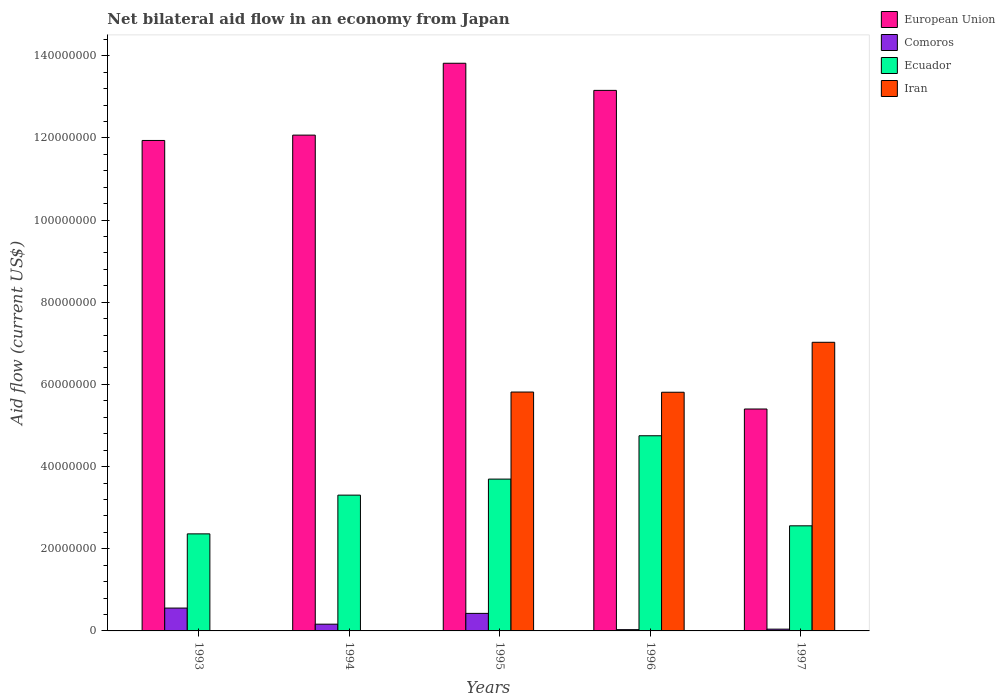How many groups of bars are there?
Keep it short and to the point. 5. Are the number of bars per tick equal to the number of legend labels?
Offer a very short reply. No. Are the number of bars on each tick of the X-axis equal?
Make the answer very short. No. Across all years, what is the maximum net bilateral aid flow in European Union?
Your answer should be compact. 1.38e+08. Across all years, what is the minimum net bilateral aid flow in European Union?
Give a very brief answer. 5.40e+07. In which year was the net bilateral aid flow in Ecuador maximum?
Give a very brief answer. 1996. What is the total net bilateral aid flow in Comoros in the graph?
Your answer should be compact. 1.22e+07. What is the difference between the net bilateral aid flow in Comoros in 1993 and that in 1994?
Make the answer very short. 3.92e+06. What is the difference between the net bilateral aid flow in Ecuador in 1997 and the net bilateral aid flow in European Union in 1996?
Keep it short and to the point. -1.06e+08. What is the average net bilateral aid flow in Iran per year?
Provide a succinct answer. 3.73e+07. In the year 1995, what is the difference between the net bilateral aid flow in European Union and net bilateral aid flow in Comoros?
Ensure brevity in your answer.  1.34e+08. What is the ratio of the net bilateral aid flow in European Union in 1995 to that in 1996?
Ensure brevity in your answer.  1.05. What is the difference between the highest and the second highest net bilateral aid flow in Ecuador?
Ensure brevity in your answer.  1.06e+07. What is the difference between the highest and the lowest net bilateral aid flow in Iran?
Provide a succinct answer. 7.02e+07. Is the sum of the net bilateral aid flow in Ecuador in 1993 and 1995 greater than the maximum net bilateral aid flow in Iran across all years?
Your response must be concise. No. How many bars are there?
Ensure brevity in your answer.  18. How many years are there in the graph?
Give a very brief answer. 5. Does the graph contain any zero values?
Your answer should be compact. Yes. How are the legend labels stacked?
Provide a succinct answer. Vertical. What is the title of the graph?
Your answer should be very brief. Net bilateral aid flow in an economy from Japan. Does "Middle East & North Africa (all income levels)" appear as one of the legend labels in the graph?
Provide a succinct answer. No. What is the label or title of the X-axis?
Offer a very short reply. Years. What is the Aid flow (current US$) in European Union in 1993?
Your answer should be compact. 1.19e+08. What is the Aid flow (current US$) in Comoros in 1993?
Offer a very short reply. 5.56e+06. What is the Aid flow (current US$) of Ecuador in 1993?
Your answer should be compact. 2.36e+07. What is the Aid flow (current US$) in European Union in 1994?
Make the answer very short. 1.21e+08. What is the Aid flow (current US$) of Comoros in 1994?
Give a very brief answer. 1.64e+06. What is the Aid flow (current US$) in Ecuador in 1994?
Ensure brevity in your answer.  3.30e+07. What is the Aid flow (current US$) in European Union in 1995?
Your response must be concise. 1.38e+08. What is the Aid flow (current US$) of Comoros in 1995?
Give a very brief answer. 4.27e+06. What is the Aid flow (current US$) of Ecuador in 1995?
Provide a short and direct response. 3.70e+07. What is the Aid flow (current US$) of Iran in 1995?
Your response must be concise. 5.81e+07. What is the Aid flow (current US$) in European Union in 1996?
Give a very brief answer. 1.32e+08. What is the Aid flow (current US$) of Comoros in 1996?
Make the answer very short. 3.10e+05. What is the Aid flow (current US$) in Ecuador in 1996?
Provide a short and direct response. 4.75e+07. What is the Aid flow (current US$) of Iran in 1996?
Offer a terse response. 5.81e+07. What is the Aid flow (current US$) of European Union in 1997?
Provide a short and direct response. 5.40e+07. What is the Aid flow (current US$) of Ecuador in 1997?
Offer a very short reply. 2.56e+07. What is the Aid flow (current US$) in Iran in 1997?
Offer a terse response. 7.02e+07. Across all years, what is the maximum Aid flow (current US$) in European Union?
Make the answer very short. 1.38e+08. Across all years, what is the maximum Aid flow (current US$) in Comoros?
Your answer should be very brief. 5.56e+06. Across all years, what is the maximum Aid flow (current US$) of Ecuador?
Provide a succinct answer. 4.75e+07. Across all years, what is the maximum Aid flow (current US$) of Iran?
Provide a short and direct response. 7.02e+07. Across all years, what is the minimum Aid flow (current US$) in European Union?
Keep it short and to the point. 5.40e+07. Across all years, what is the minimum Aid flow (current US$) of Comoros?
Your answer should be very brief. 3.10e+05. Across all years, what is the minimum Aid flow (current US$) of Ecuador?
Offer a terse response. 2.36e+07. What is the total Aid flow (current US$) in European Union in the graph?
Keep it short and to the point. 5.64e+08. What is the total Aid flow (current US$) in Comoros in the graph?
Make the answer very short. 1.22e+07. What is the total Aid flow (current US$) of Ecuador in the graph?
Keep it short and to the point. 1.67e+08. What is the total Aid flow (current US$) of Iran in the graph?
Offer a very short reply. 1.86e+08. What is the difference between the Aid flow (current US$) of European Union in 1993 and that in 1994?
Ensure brevity in your answer.  -1.30e+06. What is the difference between the Aid flow (current US$) of Comoros in 1993 and that in 1994?
Provide a succinct answer. 3.92e+06. What is the difference between the Aid flow (current US$) of Ecuador in 1993 and that in 1994?
Your answer should be compact. -9.43e+06. What is the difference between the Aid flow (current US$) of European Union in 1993 and that in 1995?
Ensure brevity in your answer.  -1.88e+07. What is the difference between the Aid flow (current US$) of Comoros in 1993 and that in 1995?
Offer a terse response. 1.29e+06. What is the difference between the Aid flow (current US$) in Ecuador in 1993 and that in 1995?
Your answer should be compact. -1.33e+07. What is the difference between the Aid flow (current US$) of European Union in 1993 and that in 1996?
Offer a very short reply. -1.22e+07. What is the difference between the Aid flow (current US$) in Comoros in 1993 and that in 1996?
Ensure brevity in your answer.  5.25e+06. What is the difference between the Aid flow (current US$) of Ecuador in 1993 and that in 1996?
Provide a short and direct response. -2.39e+07. What is the difference between the Aid flow (current US$) of European Union in 1993 and that in 1997?
Your answer should be compact. 6.54e+07. What is the difference between the Aid flow (current US$) in Comoros in 1993 and that in 1997?
Provide a succinct answer. 5.13e+06. What is the difference between the Aid flow (current US$) of Ecuador in 1993 and that in 1997?
Your answer should be compact. -1.96e+06. What is the difference between the Aid flow (current US$) of European Union in 1994 and that in 1995?
Make the answer very short. -1.75e+07. What is the difference between the Aid flow (current US$) of Comoros in 1994 and that in 1995?
Your answer should be compact. -2.63e+06. What is the difference between the Aid flow (current US$) of Ecuador in 1994 and that in 1995?
Keep it short and to the point. -3.90e+06. What is the difference between the Aid flow (current US$) of European Union in 1994 and that in 1996?
Your response must be concise. -1.09e+07. What is the difference between the Aid flow (current US$) in Comoros in 1994 and that in 1996?
Your response must be concise. 1.33e+06. What is the difference between the Aid flow (current US$) in Ecuador in 1994 and that in 1996?
Make the answer very short. -1.44e+07. What is the difference between the Aid flow (current US$) in European Union in 1994 and that in 1997?
Give a very brief answer. 6.67e+07. What is the difference between the Aid flow (current US$) in Comoros in 1994 and that in 1997?
Your answer should be compact. 1.21e+06. What is the difference between the Aid flow (current US$) of Ecuador in 1994 and that in 1997?
Offer a terse response. 7.47e+06. What is the difference between the Aid flow (current US$) of European Union in 1995 and that in 1996?
Keep it short and to the point. 6.60e+06. What is the difference between the Aid flow (current US$) in Comoros in 1995 and that in 1996?
Make the answer very short. 3.96e+06. What is the difference between the Aid flow (current US$) of Ecuador in 1995 and that in 1996?
Keep it short and to the point. -1.06e+07. What is the difference between the Aid flow (current US$) in European Union in 1995 and that in 1997?
Make the answer very short. 8.42e+07. What is the difference between the Aid flow (current US$) of Comoros in 1995 and that in 1997?
Offer a terse response. 3.84e+06. What is the difference between the Aid flow (current US$) in Ecuador in 1995 and that in 1997?
Provide a short and direct response. 1.14e+07. What is the difference between the Aid flow (current US$) in Iran in 1995 and that in 1997?
Your response must be concise. -1.21e+07. What is the difference between the Aid flow (current US$) of European Union in 1996 and that in 1997?
Keep it short and to the point. 7.76e+07. What is the difference between the Aid flow (current US$) of Comoros in 1996 and that in 1997?
Offer a terse response. -1.20e+05. What is the difference between the Aid flow (current US$) in Ecuador in 1996 and that in 1997?
Your response must be concise. 2.19e+07. What is the difference between the Aid flow (current US$) in Iran in 1996 and that in 1997?
Offer a terse response. -1.22e+07. What is the difference between the Aid flow (current US$) of European Union in 1993 and the Aid flow (current US$) of Comoros in 1994?
Ensure brevity in your answer.  1.18e+08. What is the difference between the Aid flow (current US$) of European Union in 1993 and the Aid flow (current US$) of Ecuador in 1994?
Your response must be concise. 8.63e+07. What is the difference between the Aid flow (current US$) of Comoros in 1993 and the Aid flow (current US$) of Ecuador in 1994?
Your answer should be compact. -2.75e+07. What is the difference between the Aid flow (current US$) in European Union in 1993 and the Aid flow (current US$) in Comoros in 1995?
Your answer should be compact. 1.15e+08. What is the difference between the Aid flow (current US$) in European Union in 1993 and the Aid flow (current US$) in Ecuador in 1995?
Your response must be concise. 8.24e+07. What is the difference between the Aid flow (current US$) in European Union in 1993 and the Aid flow (current US$) in Iran in 1995?
Your answer should be very brief. 6.12e+07. What is the difference between the Aid flow (current US$) in Comoros in 1993 and the Aid flow (current US$) in Ecuador in 1995?
Make the answer very short. -3.14e+07. What is the difference between the Aid flow (current US$) of Comoros in 1993 and the Aid flow (current US$) of Iran in 1995?
Offer a terse response. -5.26e+07. What is the difference between the Aid flow (current US$) in Ecuador in 1993 and the Aid flow (current US$) in Iran in 1995?
Offer a terse response. -3.45e+07. What is the difference between the Aid flow (current US$) in European Union in 1993 and the Aid flow (current US$) in Comoros in 1996?
Make the answer very short. 1.19e+08. What is the difference between the Aid flow (current US$) of European Union in 1993 and the Aid flow (current US$) of Ecuador in 1996?
Give a very brief answer. 7.19e+07. What is the difference between the Aid flow (current US$) of European Union in 1993 and the Aid flow (current US$) of Iran in 1996?
Give a very brief answer. 6.13e+07. What is the difference between the Aid flow (current US$) of Comoros in 1993 and the Aid flow (current US$) of Ecuador in 1996?
Make the answer very short. -4.19e+07. What is the difference between the Aid flow (current US$) in Comoros in 1993 and the Aid flow (current US$) in Iran in 1996?
Offer a very short reply. -5.25e+07. What is the difference between the Aid flow (current US$) of Ecuador in 1993 and the Aid flow (current US$) of Iran in 1996?
Give a very brief answer. -3.45e+07. What is the difference between the Aid flow (current US$) in European Union in 1993 and the Aid flow (current US$) in Comoros in 1997?
Provide a short and direct response. 1.19e+08. What is the difference between the Aid flow (current US$) of European Union in 1993 and the Aid flow (current US$) of Ecuador in 1997?
Your answer should be very brief. 9.38e+07. What is the difference between the Aid flow (current US$) of European Union in 1993 and the Aid flow (current US$) of Iran in 1997?
Make the answer very short. 4.91e+07. What is the difference between the Aid flow (current US$) in Comoros in 1993 and the Aid flow (current US$) in Ecuador in 1997?
Keep it short and to the point. -2.00e+07. What is the difference between the Aid flow (current US$) of Comoros in 1993 and the Aid flow (current US$) of Iran in 1997?
Provide a succinct answer. -6.47e+07. What is the difference between the Aid flow (current US$) of Ecuador in 1993 and the Aid flow (current US$) of Iran in 1997?
Your response must be concise. -4.66e+07. What is the difference between the Aid flow (current US$) in European Union in 1994 and the Aid flow (current US$) in Comoros in 1995?
Your answer should be compact. 1.16e+08. What is the difference between the Aid flow (current US$) of European Union in 1994 and the Aid flow (current US$) of Ecuador in 1995?
Provide a short and direct response. 8.37e+07. What is the difference between the Aid flow (current US$) in European Union in 1994 and the Aid flow (current US$) in Iran in 1995?
Your answer should be compact. 6.25e+07. What is the difference between the Aid flow (current US$) of Comoros in 1994 and the Aid flow (current US$) of Ecuador in 1995?
Keep it short and to the point. -3.53e+07. What is the difference between the Aid flow (current US$) in Comoros in 1994 and the Aid flow (current US$) in Iran in 1995?
Your response must be concise. -5.65e+07. What is the difference between the Aid flow (current US$) in Ecuador in 1994 and the Aid flow (current US$) in Iran in 1995?
Make the answer very short. -2.51e+07. What is the difference between the Aid flow (current US$) of European Union in 1994 and the Aid flow (current US$) of Comoros in 1996?
Ensure brevity in your answer.  1.20e+08. What is the difference between the Aid flow (current US$) in European Union in 1994 and the Aid flow (current US$) in Ecuador in 1996?
Make the answer very short. 7.32e+07. What is the difference between the Aid flow (current US$) in European Union in 1994 and the Aid flow (current US$) in Iran in 1996?
Provide a succinct answer. 6.26e+07. What is the difference between the Aid flow (current US$) in Comoros in 1994 and the Aid flow (current US$) in Ecuador in 1996?
Ensure brevity in your answer.  -4.59e+07. What is the difference between the Aid flow (current US$) in Comoros in 1994 and the Aid flow (current US$) in Iran in 1996?
Your response must be concise. -5.64e+07. What is the difference between the Aid flow (current US$) in Ecuador in 1994 and the Aid flow (current US$) in Iran in 1996?
Offer a terse response. -2.50e+07. What is the difference between the Aid flow (current US$) in European Union in 1994 and the Aid flow (current US$) in Comoros in 1997?
Make the answer very short. 1.20e+08. What is the difference between the Aid flow (current US$) of European Union in 1994 and the Aid flow (current US$) of Ecuador in 1997?
Give a very brief answer. 9.51e+07. What is the difference between the Aid flow (current US$) in European Union in 1994 and the Aid flow (current US$) in Iran in 1997?
Your response must be concise. 5.04e+07. What is the difference between the Aid flow (current US$) of Comoros in 1994 and the Aid flow (current US$) of Ecuador in 1997?
Offer a very short reply. -2.39e+07. What is the difference between the Aid flow (current US$) in Comoros in 1994 and the Aid flow (current US$) in Iran in 1997?
Provide a succinct answer. -6.86e+07. What is the difference between the Aid flow (current US$) of Ecuador in 1994 and the Aid flow (current US$) of Iran in 1997?
Make the answer very short. -3.72e+07. What is the difference between the Aid flow (current US$) in European Union in 1995 and the Aid flow (current US$) in Comoros in 1996?
Keep it short and to the point. 1.38e+08. What is the difference between the Aid flow (current US$) in European Union in 1995 and the Aid flow (current US$) in Ecuador in 1996?
Keep it short and to the point. 9.07e+07. What is the difference between the Aid flow (current US$) in European Union in 1995 and the Aid flow (current US$) in Iran in 1996?
Provide a short and direct response. 8.01e+07. What is the difference between the Aid flow (current US$) of Comoros in 1995 and the Aid flow (current US$) of Ecuador in 1996?
Provide a succinct answer. -4.32e+07. What is the difference between the Aid flow (current US$) of Comoros in 1995 and the Aid flow (current US$) of Iran in 1996?
Your response must be concise. -5.38e+07. What is the difference between the Aid flow (current US$) in Ecuador in 1995 and the Aid flow (current US$) in Iran in 1996?
Keep it short and to the point. -2.11e+07. What is the difference between the Aid flow (current US$) of European Union in 1995 and the Aid flow (current US$) of Comoros in 1997?
Offer a terse response. 1.38e+08. What is the difference between the Aid flow (current US$) of European Union in 1995 and the Aid flow (current US$) of Ecuador in 1997?
Give a very brief answer. 1.13e+08. What is the difference between the Aid flow (current US$) in European Union in 1995 and the Aid flow (current US$) in Iran in 1997?
Offer a very short reply. 6.79e+07. What is the difference between the Aid flow (current US$) of Comoros in 1995 and the Aid flow (current US$) of Ecuador in 1997?
Ensure brevity in your answer.  -2.13e+07. What is the difference between the Aid flow (current US$) of Comoros in 1995 and the Aid flow (current US$) of Iran in 1997?
Provide a succinct answer. -6.60e+07. What is the difference between the Aid flow (current US$) in Ecuador in 1995 and the Aid flow (current US$) in Iran in 1997?
Provide a succinct answer. -3.33e+07. What is the difference between the Aid flow (current US$) in European Union in 1996 and the Aid flow (current US$) in Comoros in 1997?
Keep it short and to the point. 1.31e+08. What is the difference between the Aid flow (current US$) in European Union in 1996 and the Aid flow (current US$) in Ecuador in 1997?
Provide a short and direct response. 1.06e+08. What is the difference between the Aid flow (current US$) in European Union in 1996 and the Aid flow (current US$) in Iran in 1997?
Provide a short and direct response. 6.13e+07. What is the difference between the Aid flow (current US$) in Comoros in 1996 and the Aid flow (current US$) in Ecuador in 1997?
Your answer should be compact. -2.53e+07. What is the difference between the Aid flow (current US$) in Comoros in 1996 and the Aid flow (current US$) in Iran in 1997?
Give a very brief answer. -6.99e+07. What is the difference between the Aid flow (current US$) of Ecuador in 1996 and the Aid flow (current US$) of Iran in 1997?
Provide a short and direct response. -2.28e+07. What is the average Aid flow (current US$) of European Union per year?
Give a very brief answer. 1.13e+08. What is the average Aid flow (current US$) in Comoros per year?
Make the answer very short. 2.44e+06. What is the average Aid flow (current US$) of Ecuador per year?
Keep it short and to the point. 3.33e+07. What is the average Aid flow (current US$) of Iran per year?
Keep it short and to the point. 3.73e+07. In the year 1993, what is the difference between the Aid flow (current US$) in European Union and Aid flow (current US$) in Comoros?
Provide a short and direct response. 1.14e+08. In the year 1993, what is the difference between the Aid flow (current US$) of European Union and Aid flow (current US$) of Ecuador?
Keep it short and to the point. 9.58e+07. In the year 1993, what is the difference between the Aid flow (current US$) of Comoros and Aid flow (current US$) of Ecuador?
Offer a terse response. -1.81e+07. In the year 1994, what is the difference between the Aid flow (current US$) of European Union and Aid flow (current US$) of Comoros?
Your answer should be very brief. 1.19e+08. In the year 1994, what is the difference between the Aid flow (current US$) in European Union and Aid flow (current US$) in Ecuador?
Keep it short and to the point. 8.76e+07. In the year 1994, what is the difference between the Aid flow (current US$) of Comoros and Aid flow (current US$) of Ecuador?
Give a very brief answer. -3.14e+07. In the year 1995, what is the difference between the Aid flow (current US$) in European Union and Aid flow (current US$) in Comoros?
Provide a succinct answer. 1.34e+08. In the year 1995, what is the difference between the Aid flow (current US$) of European Union and Aid flow (current US$) of Ecuador?
Your answer should be compact. 1.01e+08. In the year 1995, what is the difference between the Aid flow (current US$) in European Union and Aid flow (current US$) in Iran?
Make the answer very short. 8.00e+07. In the year 1995, what is the difference between the Aid flow (current US$) of Comoros and Aid flow (current US$) of Ecuador?
Your response must be concise. -3.27e+07. In the year 1995, what is the difference between the Aid flow (current US$) in Comoros and Aid flow (current US$) in Iran?
Your answer should be very brief. -5.39e+07. In the year 1995, what is the difference between the Aid flow (current US$) of Ecuador and Aid flow (current US$) of Iran?
Ensure brevity in your answer.  -2.12e+07. In the year 1996, what is the difference between the Aid flow (current US$) of European Union and Aid flow (current US$) of Comoros?
Offer a terse response. 1.31e+08. In the year 1996, what is the difference between the Aid flow (current US$) of European Union and Aid flow (current US$) of Ecuador?
Provide a succinct answer. 8.41e+07. In the year 1996, what is the difference between the Aid flow (current US$) of European Union and Aid flow (current US$) of Iran?
Offer a very short reply. 7.35e+07. In the year 1996, what is the difference between the Aid flow (current US$) in Comoros and Aid flow (current US$) in Ecuador?
Give a very brief answer. -4.72e+07. In the year 1996, what is the difference between the Aid flow (current US$) of Comoros and Aid flow (current US$) of Iran?
Your answer should be very brief. -5.78e+07. In the year 1996, what is the difference between the Aid flow (current US$) of Ecuador and Aid flow (current US$) of Iran?
Provide a short and direct response. -1.06e+07. In the year 1997, what is the difference between the Aid flow (current US$) of European Union and Aid flow (current US$) of Comoros?
Your answer should be very brief. 5.36e+07. In the year 1997, what is the difference between the Aid flow (current US$) in European Union and Aid flow (current US$) in Ecuador?
Make the answer very short. 2.84e+07. In the year 1997, what is the difference between the Aid flow (current US$) in European Union and Aid flow (current US$) in Iran?
Offer a very short reply. -1.62e+07. In the year 1997, what is the difference between the Aid flow (current US$) of Comoros and Aid flow (current US$) of Ecuador?
Give a very brief answer. -2.52e+07. In the year 1997, what is the difference between the Aid flow (current US$) of Comoros and Aid flow (current US$) of Iran?
Offer a very short reply. -6.98e+07. In the year 1997, what is the difference between the Aid flow (current US$) of Ecuador and Aid flow (current US$) of Iran?
Keep it short and to the point. -4.47e+07. What is the ratio of the Aid flow (current US$) of European Union in 1993 to that in 1994?
Offer a terse response. 0.99. What is the ratio of the Aid flow (current US$) of Comoros in 1993 to that in 1994?
Make the answer very short. 3.39. What is the ratio of the Aid flow (current US$) in Ecuador in 1993 to that in 1994?
Offer a very short reply. 0.71. What is the ratio of the Aid flow (current US$) in European Union in 1993 to that in 1995?
Provide a succinct answer. 0.86. What is the ratio of the Aid flow (current US$) of Comoros in 1993 to that in 1995?
Offer a very short reply. 1.3. What is the ratio of the Aid flow (current US$) of Ecuador in 1993 to that in 1995?
Offer a very short reply. 0.64. What is the ratio of the Aid flow (current US$) of European Union in 1993 to that in 1996?
Offer a terse response. 0.91. What is the ratio of the Aid flow (current US$) of Comoros in 1993 to that in 1996?
Offer a very short reply. 17.94. What is the ratio of the Aid flow (current US$) of Ecuador in 1993 to that in 1996?
Offer a very short reply. 0.5. What is the ratio of the Aid flow (current US$) of European Union in 1993 to that in 1997?
Make the answer very short. 2.21. What is the ratio of the Aid flow (current US$) in Comoros in 1993 to that in 1997?
Offer a terse response. 12.93. What is the ratio of the Aid flow (current US$) of Ecuador in 1993 to that in 1997?
Keep it short and to the point. 0.92. What is the ratio of the Aid flow (current US$) in European Union in 1994 to that in 1995?
Offer a terse response. 0.87. What is the ratio of the Aid flow (current US$) of Comoros in 1994 to that in 1995?
Make the answer very short. 0.38. What is the ratio of the Aid flow (current US$) in Ecuador in 1994 to that in 1995?
Your answer should be compact. 0.89. What is the ratio of the Aid flow (current US$) in European Union in 1994 to that in 1996?
Your answer should be very brief. 0.92. What is the ratio of the Aid flow (current US$) in Comoros in 1994 to that in 1996?
Give a very brief answer. 5.29. What is the ratio of the Aid flow (current US$) in Ecuador in 1994 to that in 1996?
Ensure brevity in your answer.  0.7. What is the ratio of the Aid flow (current US$) of European Union in 1994 to that in 1997?
Give a very brief answer. 2.23. What is the ratio of the Aid flow (current US$) of Comoros in 1994 to that in 1997?
Your answer should be very brief. 3.81. What is the ratio of the Aid flow (current US$) in Ecuador in 1994 to that in 1997?
Your answer should be compact. 1.29. What is the ratio of the Aid flow (current US$) of European Union in 1995 to that in 1996?
Your answer should be compact. 1.05. What is the ratio of the Aid flow (current US$) in Comoros in 1995 to that in 1996?
Give a very brief answer. 13.77. What is the ratio of the Aid flow (current US$) of Ecuador in 1995 to that in 1996?
Keep it short and to the point. 0.78. What is the ratio of the Aid flow (current US$) in Iran in 1995 to that in 1996?
Keep it short and to the point. 1. What is the ratio of the Aid flow (current US$) of European Union in 1995 to that in 1997?
Offer a very short reply. 2.56. What is the ratio of the Aid flow (current US$) of Comoros in 1995 to that in 1997?
Provide a short and direct response. 9.93. What is the ratio of the Aid flow (current US$) in Ecuador in 1995 to that in 1997?
Offer a terse response. 1.44. What is the ratio of the Aid flow (current US$) of Iran in 1995 to that in 1997?
Your response must be concise. 0.83. What is the ratio of the Aid flow (current US$) of European Union in 1996 to that in 1997?
Keep it short and to the point. 2.44. What is the ratio of the Aid flow (current US$) of Comoros in 1996 to that in 1997?
Your answer should be compact. 0.72. What is the ratio of the Aid flow (current US$) of Ecuador in 1996 to that in 1997?
Make the answer very short. 1.86. What is the ratio of the Aid flow (current US$) in Iran in 1996 to that in 1997?
Your answer should be compact. 0.83. What is the difference between the highest and the second highest Aid flow (current US$) in European Union?
Keep it short and to the point. 6.60e+06. What is the difference between the highest and the second highest Aid flow (current US$) in Comoros?
Your response must be concise. 1.29e+06. What is the difference between the highest and the second highest Aid flow (current US$) in Ecuador?
Your response must be concise. 1.06e+07. What is the difference between the highest and the second highest Aid flow (current US$) in Iran?
Provide a succinct answer. 1.21e+07. What is the difference between the highest and the lowest Aid flow (current US$) of European Union?
Make the answer very short. 8.42e+07. What is the difference between the highest and the lowest Aid flow (current US$) of Comoros?
Make the answer very short. 5.25e+06. What is the difference between the highest and the lowest Aid flow (current US$) in Ecuador?
Keep it short and to the point. 2.39e+07. What is the difference between the highest and the lowest Aid flow (current US$) of Iran?
Keep it short and to the point. 7.02e+07. 